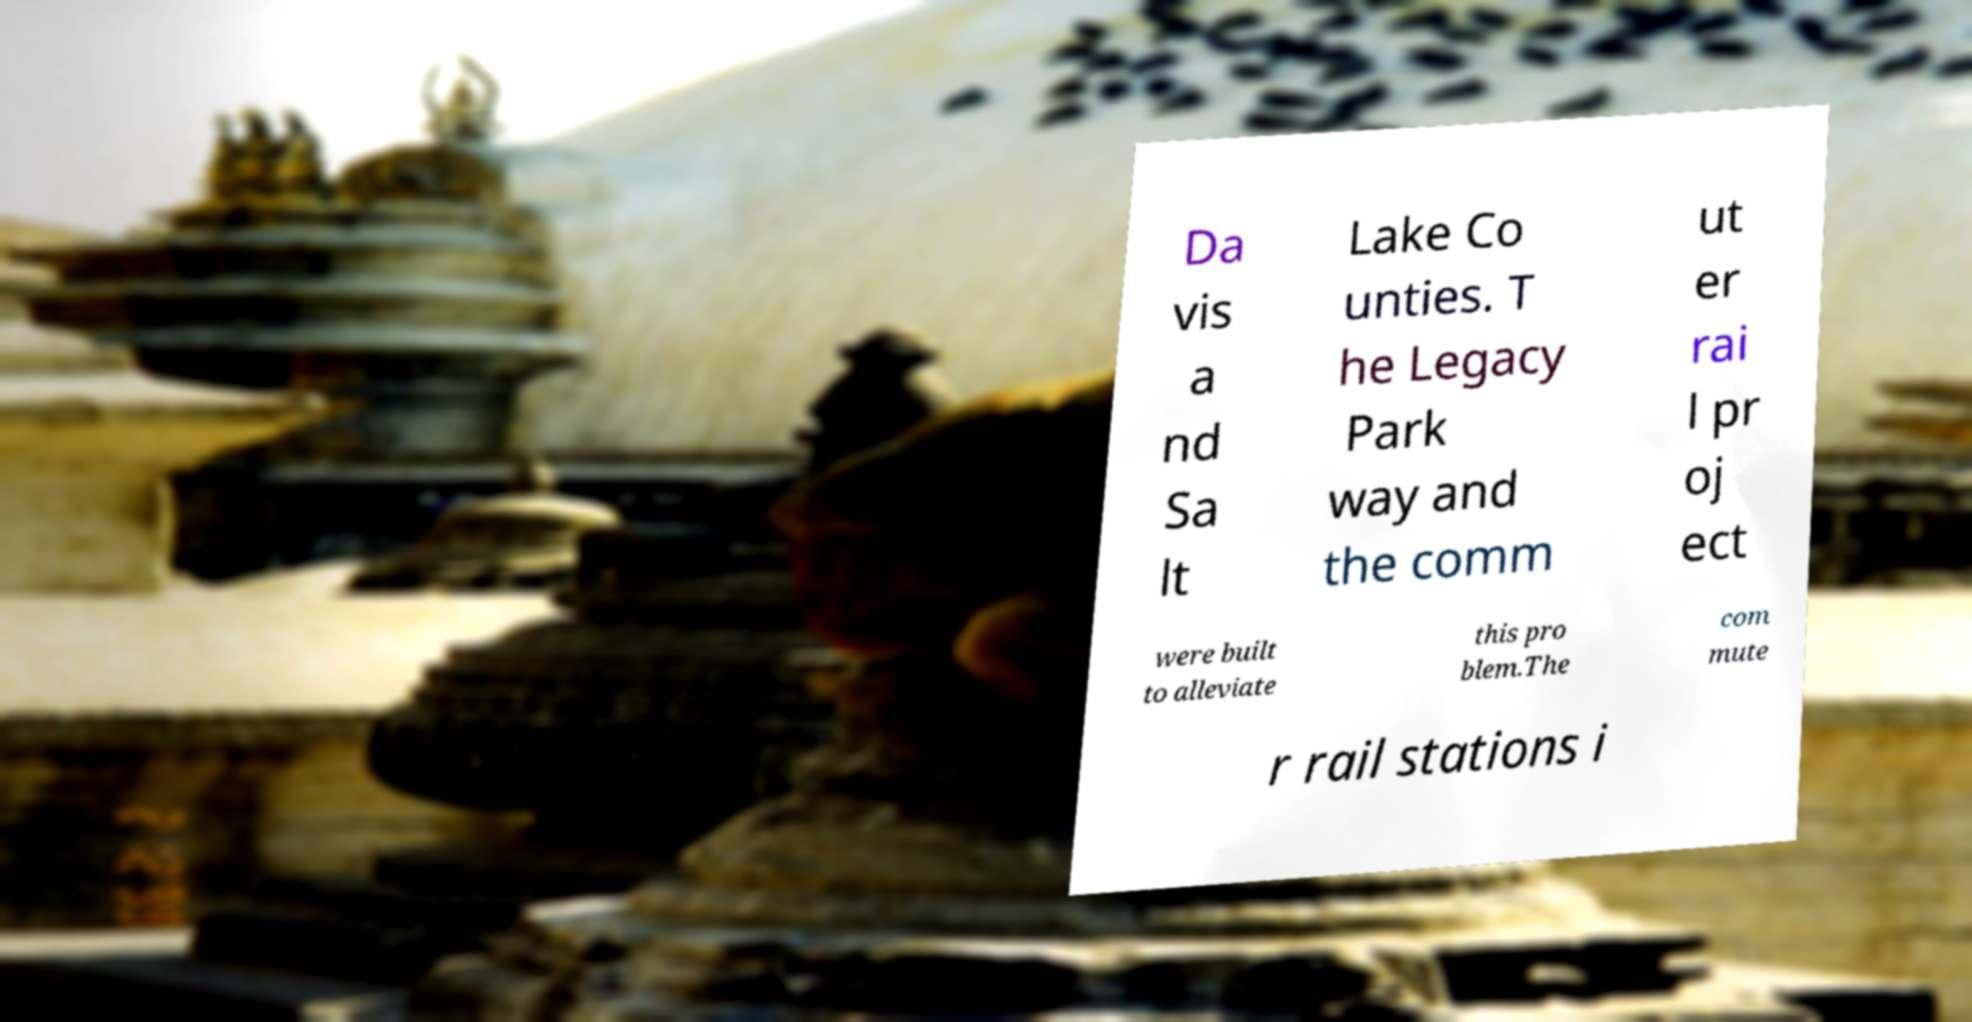Please read and relay the text visible in this image. What does it say? Da vis a nd Sa lt Lake Co unties. T he Legacy Park way and the comm ut er rai l pr oj ect were built to alleviate this pro blem.The com mute r rail stations i 